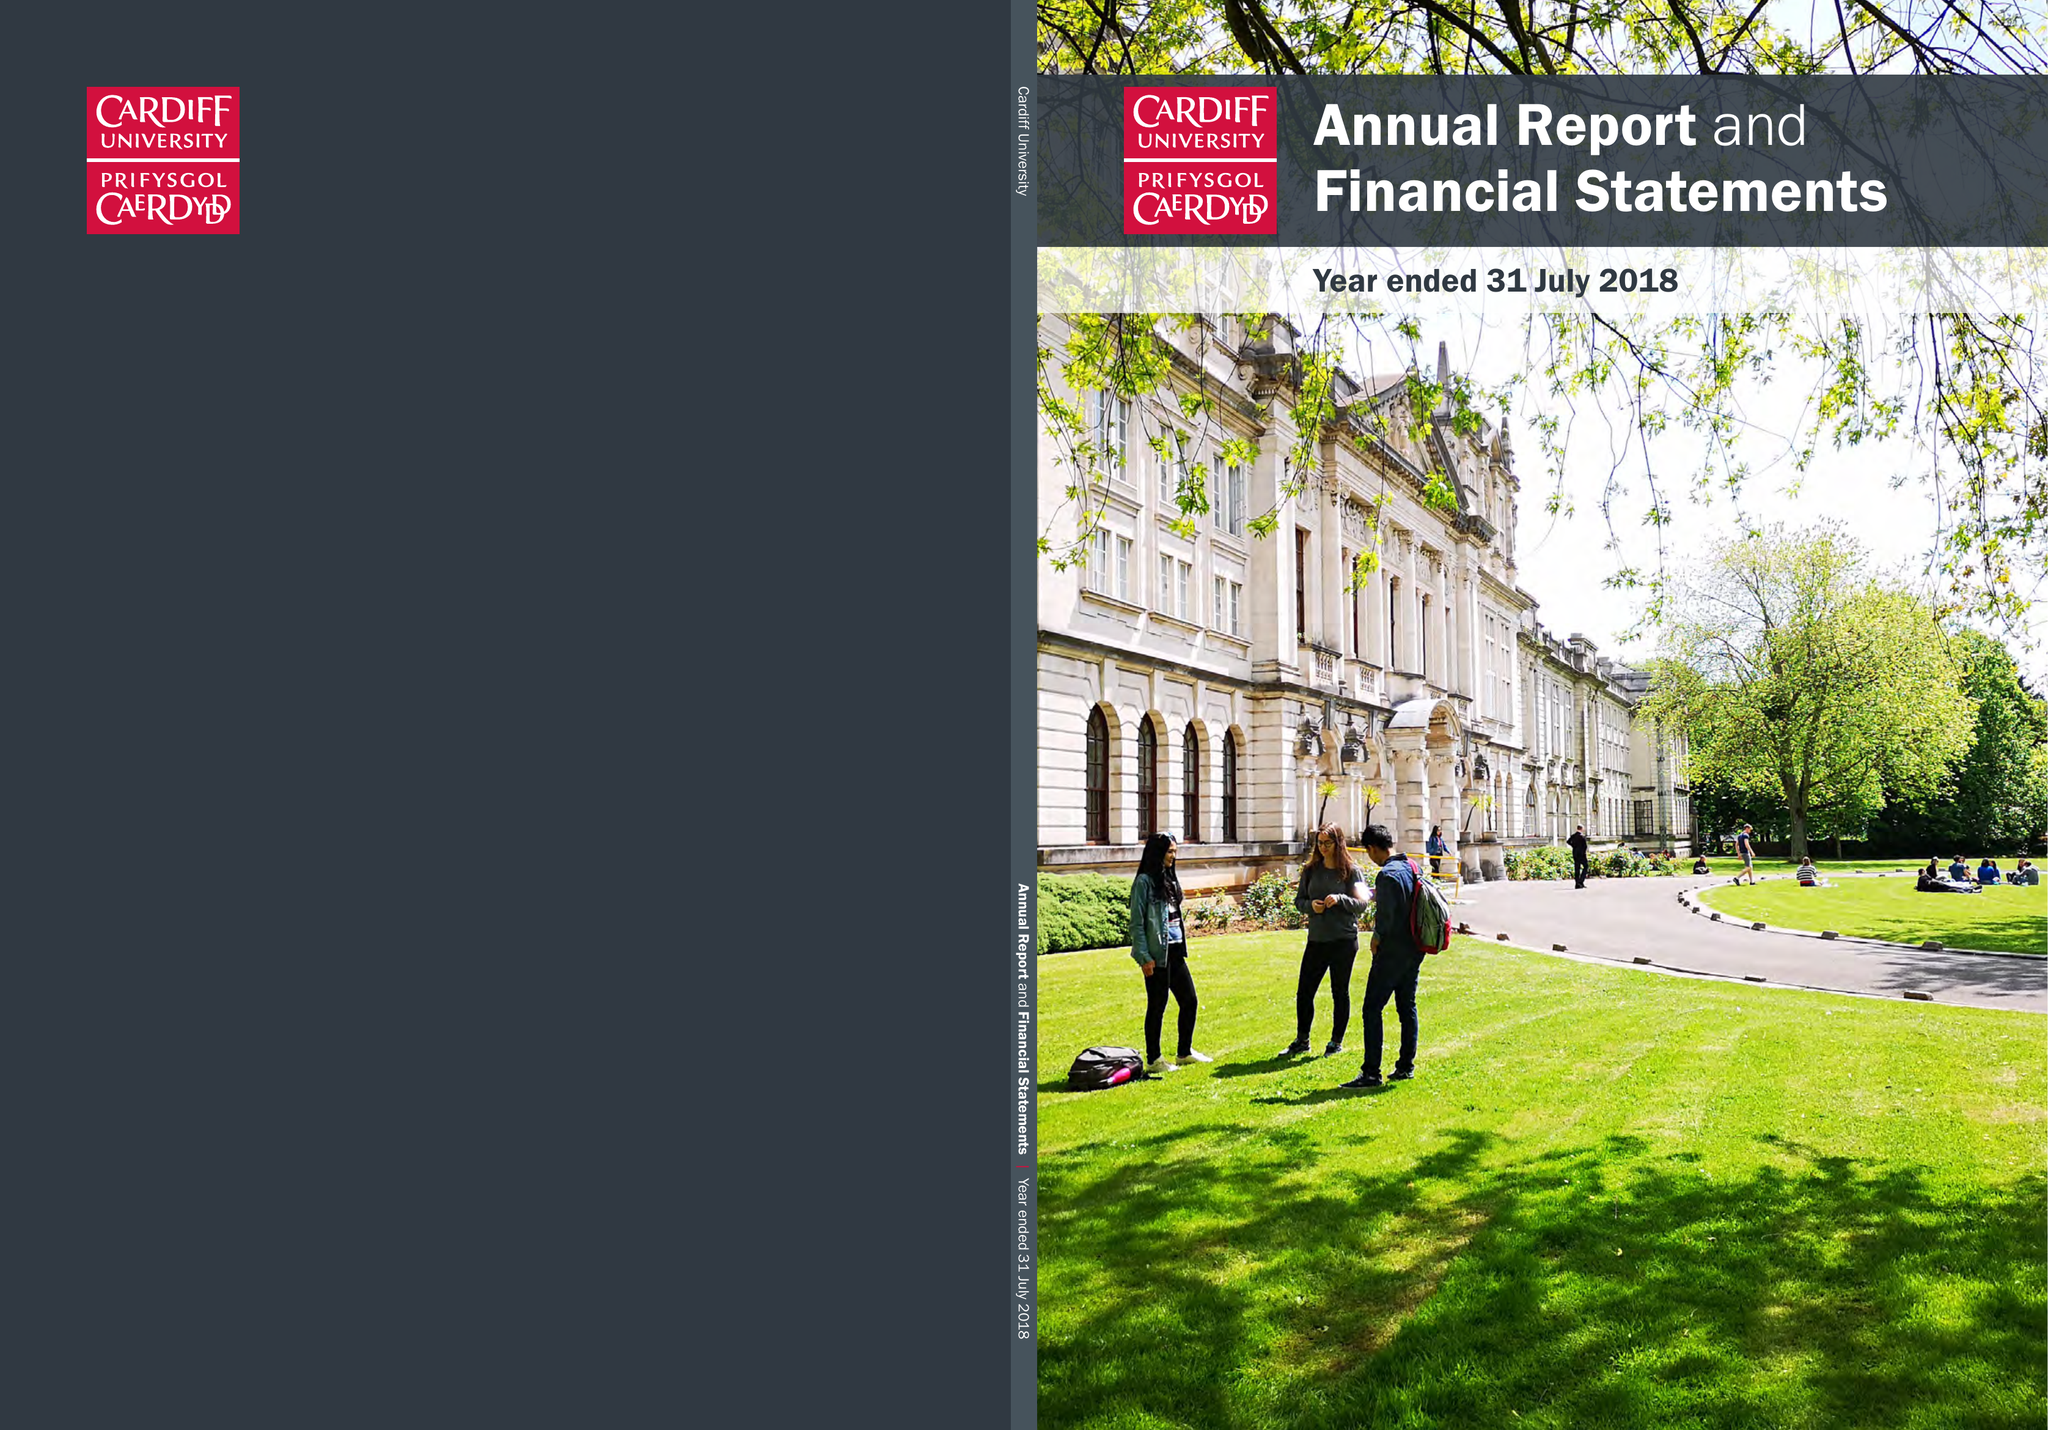What is the value for the charity_number?
Answer the question using a single word or phrase. 1136855 